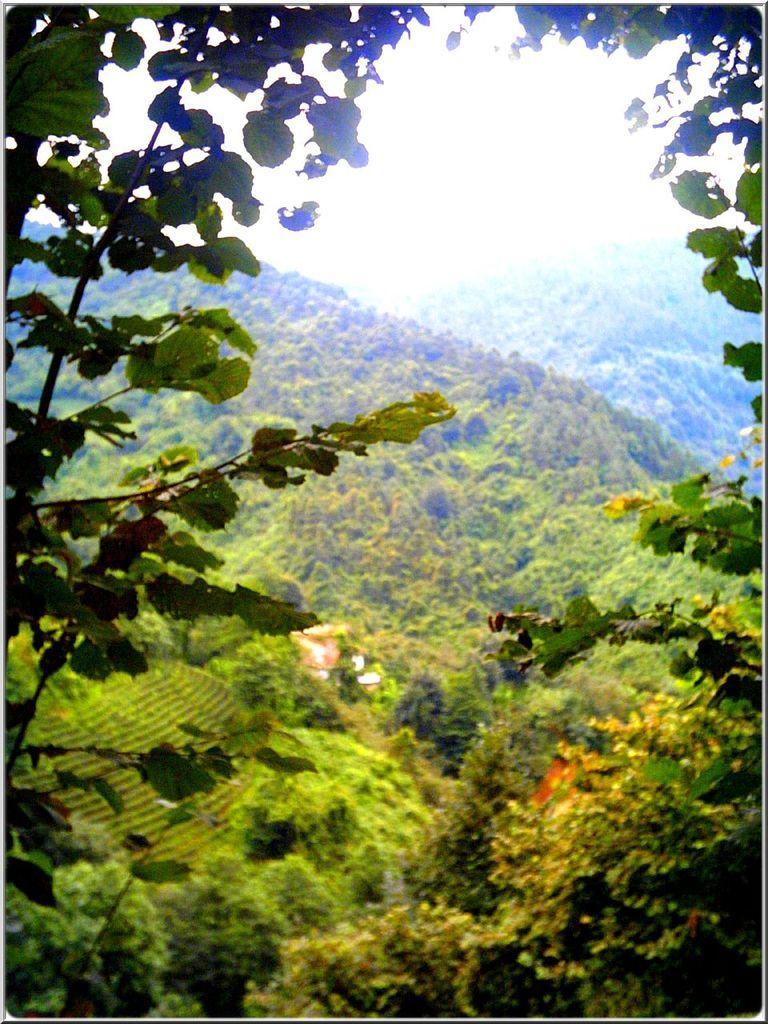Could you give a brief overview of what you see in this image? In the center of the image there are trees, hills and sky. 